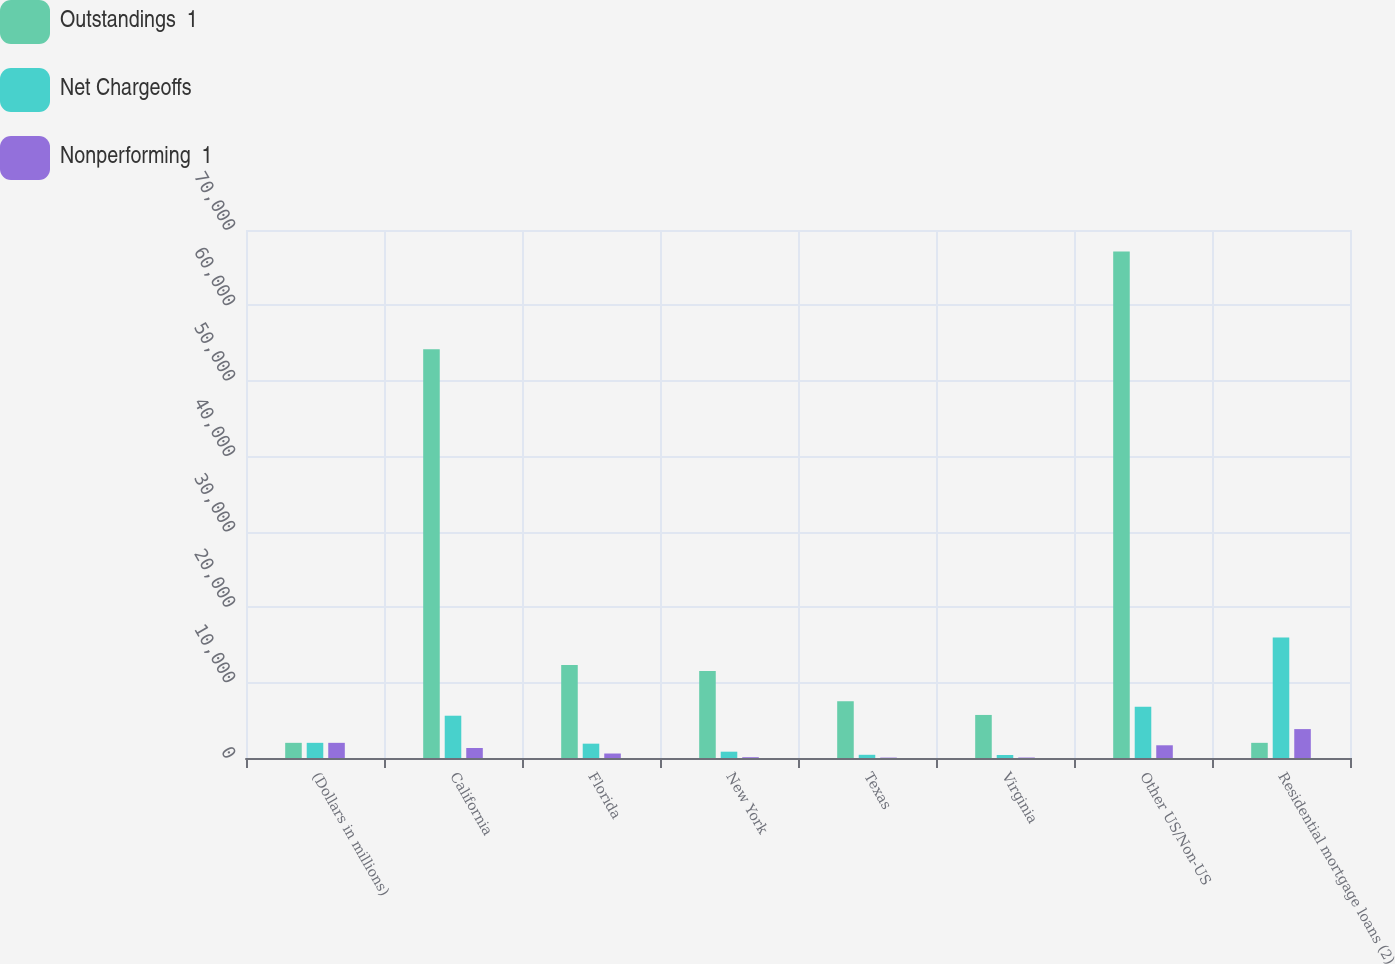Convert chart. <chart><loc_0><loc_0><loc_500><loc_500><stacked_bar_chart><ecel><fcel>(Dollars in millions)<fcel>California<fcel>Florida<fcel>New York<fcel>Texas<fcel>Virginia<fcel>Other US/Non-US<fcel>Residential mortgage loans (2)<nl><fcel>Outstandings  1<fcel>2011<fcel>54203<fcel>12338<fcel>11539<fcel>7525<fcel>5709<fcel>67156<fcel>2011<nl><fcel>Net Chargeoffs<fcel>2011<fcel>5606<fcel>1900<fcel>838<fcel>425<fcel>399<fcel>6802<fcel>15970<nl><fcel>Nonperforming  1<fcel>2011<fcel>1326<fcel>595<fcel>106<fcel>55<fcel>64<fcel>1686<fcel>3832<nl></chart> 